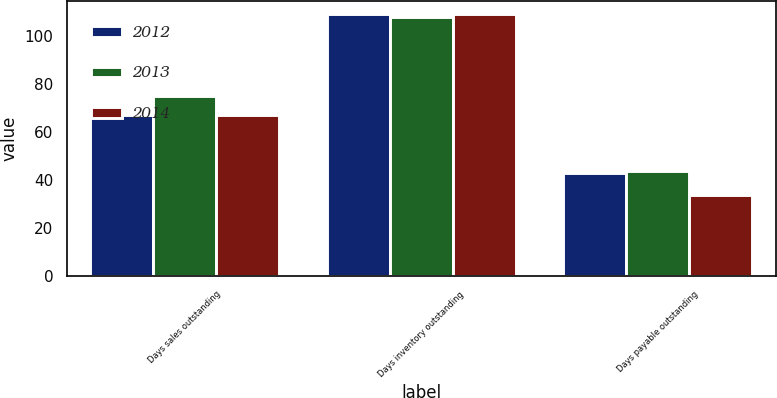<chart> <loc_0><loc_0><loc_500><loc_500><stacked_bar_chart><ecel><fcel>Days sales outstanding<fcel>Days inventory outstanding<fcel>Days payable outstanding<nl><fcel>2012<fcel>67<fcel>109<fcel>43<nl><fcel>2013<fcel>75<fcel>108<fcel>44<nl><fcel>2014<fcel>67<fcel>109<fcel>34<nl></chart> 